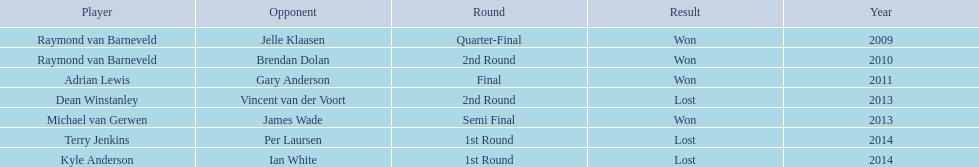What was the names of all the players? Raymond van Barneveld, Raymond van Barneveld, Adrian Lewis, Dean Winstanley, Michael van Gerwen, Terry Jenkins, Kyle Anderson. What years were the championship offered? 2009, 2010, 2011, 2013, 2013, 2014, 2014. Of these, who played in 2011? Adrian Lewis. Would you be able to parse every entry in this table? {'header': ['Player', 'Opponent', 'Round', 'Result', 'Year'], 'rows': [['Raymond van Barneveld', 'Jelle Klaasen', 'Quarter-Final', 'Won', '2009'], ['Raymond van Barneveld', 'Brendan Dolan', '2nd Round', 'Won', '2010'], ['Adrian Lewis', 'Gary Anderson', 'Final', 'Won', '2011'], ['Dean Winstanley', 'Vincent van der Voort', '2nd Round', 'Lost', '2013'], ['Michael van Gerwen', 'James Wade', 'Semi Final', 'Won', '2013'], ['Terry Jenkins', 'Per Laursen', '1st Round', 'Lost', '2014'], ['Kyle Anderson', 'Ian White', '1st Round', 'Lost', '2014']]} 